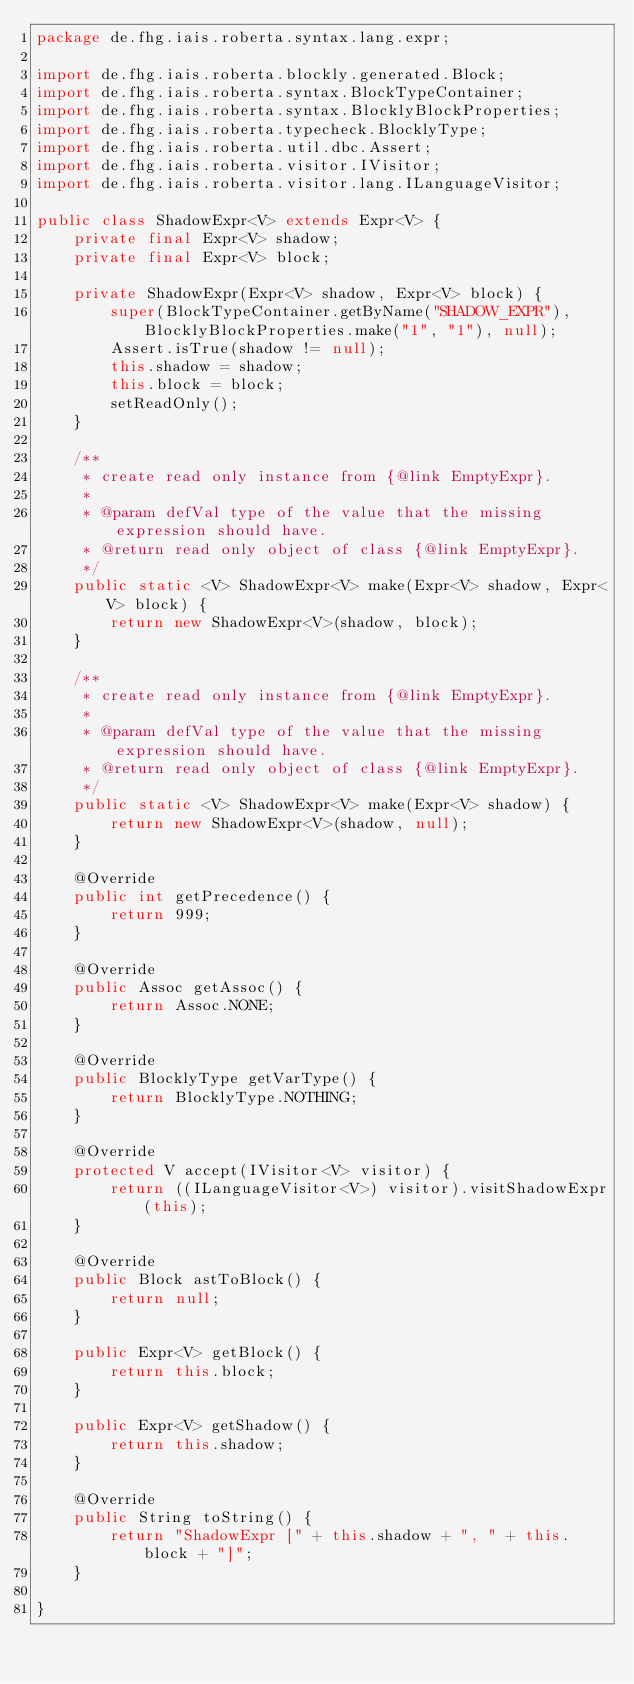Convert code to text. <code><loc_0><loc_0><loc_500><loc_500><_Java_>package de.fhg.iais.roberta.syntax.lang.expr;

import de.fhg.iais.roberta.blockly.generated.Block;
import de.fhg.iais.roberta.syntax.BlockTypeContainer;
import de.fhg.iais.roberta.syntax.BlocklyBlockProperties;
import de.fhg.iais.roberta.typecheck.BlocklyType;
import de.fhg.iais.roberta.util.dbc.Assert;
import de.fhg.iais.roberta.visitor.IVisitor;
import de.fhg.iais.roberta.visitor.lang.ILanguageVisitor;

public class ShadowExpr<V> extends Expr<V> {
    private final Expr<V> shadow;
    private final Expr<V> block;

    private ShadowExpr(Expr<V> shadow, Expr<V> block) {
        super(BlockTypeContainer.getByName("SHADOW_EXPR"), BlocklyBlockProperties.make("1", "1"), null);
        Assert.isTrue(shadow != null);
        this.shadow = shadow;
        this.block = block;
        setReadOnly();
    }

    /**
     * create read only instance from {@link EmptyExpr}.
     *
     * @param defVal type of the value that the missing expression should have.
     * @return read only object of class {@link EmptyExpr}.
     */
    public static <V> ShadowExpr<V> make(Expr<V> shadow, Expr<V> block) {
        return new ShadowExpr<V>(shadow, block);
    }

    /**
     * create read only instance from {@link EmptyExpr}.
     *
     * @param defVal type of the value that the missing expression should have.
     * @return read only object of class {@link EmptyExpr}.
     */
    public static <V> ShadowExpr<V> make(Expr<V> shadow) {
        return new ShadowExpr<V>(shadow, null);
    }

    @Override
    public int getPrecedence() {
        return 999;
    }

    @Override
    public Assoc getAssoc() {
        return Assoc.NONE;
    }

    @Override
    public BlocklyType getVarType() {
        return BlocklyType.NOTHING;
    }

    @Override
    protected V accept(IVisitor<V> visitor) {
        return ((ILanguageVisitor<V>) visitor).visitShadowExpr(this);
    }

    @Override
    public Block astToBlock() {
        return null;
    }

    public Expr<V> getBlock() {
        return this.block;
    }

    public Expr<V> getShadow() {
        return this.shadow;
    }

    @Override
    public String toString() {
        return "ShadowExpr [" + this.shadow + ", " + this.block + "]";
    }

}
</code> 